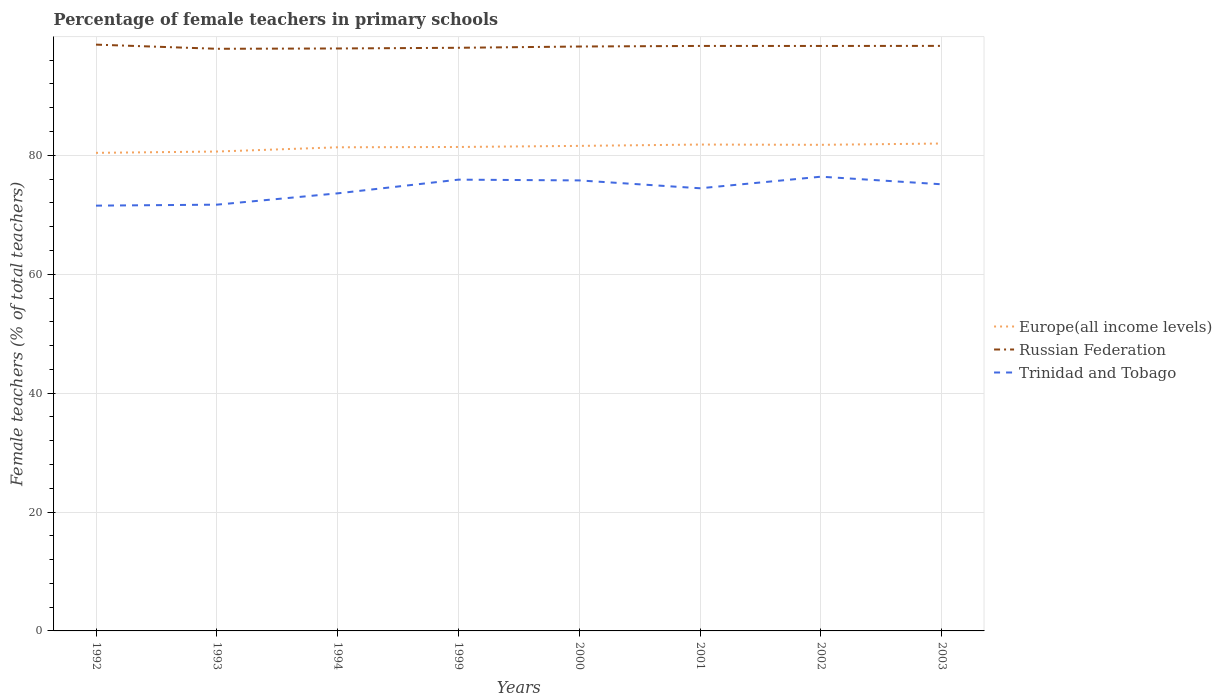How many different coloured lines are there?
Make the answer very short. 3. Does the line corresponding to Trinidad and Tobago intersect with the line corresponding to Europe(all income levels)?
Provide a succinct answer. No. Is the number of lines equal to the number of legend labels?
Your answer should be compact. Yes. Across all years, what is the maximum percentage of female teachers in Russian Federation?
Provide a short and direct response. 97.92. In which year was the percentage of female teachers in Trinidad and Tobago maximum?
Offer a very short reply. 1992. What is the total percentage of female teachers in Russian Federation in the graph?
Provide a succinct answer. -0.11. What is the difference between the highest and the second highest percentage of female teachers in Trinidad and Tobago?
Keep it short and to the point. 4.87. How many years are there in the graph?
Your answer should be very brief. 8. What is the difference between two consecutive major ticks on the Y-axis?
Your answer should be compact. 20. Does the graph contain grids?
Provide a succinct answer. Yes. What is the title of the graph?
Offer a very short reply. Percentage of female teachers in primary schools. What is the label or title of the Y-axis?
Give a very brief answer. Female teachers (% of total teachers). What is the Female teachers (% of total teachers) in Europe(all income levels) in 1992?
Offer a very short reply. 80.42. What is the Female teachers (% of total teachers) in Russian Federation in 1992?
Offer a very short reply. 98.62. What is the Female teachers (% of total teachers) in Trinidad and Tobago in 1992?
Make the answer very short. 71.54. What is the Female teachers (% of total teachers) in Europe(all income levels) in 1993?
Make the answer very short. 80.64. What is the Female teachers (% of total teachers) in Russian Federation in 1993?
Give a very brief answer. 97.92. What is the Female teachers (% of total teachers) of Trinidad and Tobago in 1993?
Provide a succinct answer. 71.7. What is the Female teachers (% of total teachers) in Europe(all income levels) in 1994?
Offer a very short reply. 81.35. What is the Female teachers (% of total teachers) in Russian Federation in 1994?
Your response must be concise. 97.97. What is the Female teachers (% of total teachers) of Trinidad and Tobago in 1994?
Your answer should be compact. 73.61. What is the Female teachers (% of total teachers) of Europe(all income levels) in 1999?
Offer a terse response. 81.41. What is the Female teachers (% of total teachers) in Russian Federation in 1999?
Offer a very short reply. 98.09. What is the Female teachers (% of total teachers) of Trinidad and Tobago in 1999?
Your response must be concise. 75.91. What is the Female teachers (% of total teachers) of Europe(all income levels) in 2000?
Offer a very short reply. 81.59. What is the Female teachers (% of total teachers) of Russian Federation in 2000?
Your response must be concise. 98.3. What is the Female teachers (% of total teachers) of Trinidad and Tobago in 2000?
Provide a succinct answer. 75.78. What is the Female teachers (% of total teachers) in Europe(all income levels) in 2001?
Your response must be concise. 81.81. What is the Female teachers (% of total teachers) of Russian Federation in 2001?
Ensure brevity in your answer.  98.4. What is the Female teachers (% of total teachers) of Trinidad and Tobago in 2001?
Offer a terse response. 74.46. What is the Female teachers (% of total teachers) of Europe(all income levels) in 2002?
Keep it short and to the point. 81.77. What is the Female teachers (% of total teachers) in Russian Federation in 2002?
Ensure brevity in your answer.  98.4. What is the Female teachers (% of total teachers) of Trinidad and Tobago in 2002?
Provide a short and direct response. 76.41. What is the Female teachers (% of total teachers) in Europe(all income levels) in 2003?
Offer a terse response. 81.99. What is the Female teachers (% of total teachers) in Russian Federation in 2003?
Provide a short and direct response. 98.41. What is the Female teachers (% of total teachers) of Trinidad and Tobago in 2003?
Make the answer very short. 75.13. Across all years, what is the maximum Female teachers (% of total teachers) of Europe(all income levels)?
Keep it short and to the point. 81.99. Across all years, what is the maximum Female teachers (% of total teachers) in Russian Federation?
Ensure brevity in your answer.  98.62. Across all years, what is the maximum Female teachers (% of total teachers) of Trinidad and Tobago?
Your answer should be compact. 76.41. Across all years, what is the minimum Female teachers (% of total teachers) of Europe(all income levels)?
Keep it short and to the point. 80.42. Across all years, what is the minimum Female teachers (% of total teachers) in Russian Federation?
Your answer should be very brief. 97.92. Across all years, what is the minimum Female teachers (% of total teachers) of Trinidad and Tobago?
Your response must be concise. 71.54. What is the total Female teachers (% of total teachers) in Europe(all income levels) in the graph?
Your response must be concise. 650.98. What is the total Female teachers (% of total teachers) in Russian Federation in the graph?
Keep it short and to the point. 786.13. What is the total Female teachers (% of total teachers) of Trinidad and Tobago in the graph?
Keep it short and to the point. 594.53. What is the difference between the Female teachers (% of total teachers) of Europe(all income levels) in 1992 and that in 1993?
Your response must be concise. -0.22. What is the difference between the Female teachers (% of total teachers) of Russian Federation in 1992 and that in 1993?
Keep it short and to the point. 0.7. What is the difference between the Female teachers (% of total teachers) of Trinidad and Tobago in 1992 and that in 1993?
Your answer should be compact. -0.16. What is the difference between the Female teachers (% of total teachers) of Europe(all income levels) in 1992 and that in 1994?
Offer a terse response. -0.93. What is the difference between the Female teachers (% of total teachers) of Russian Federation in 1992 and that in 1994?
Your response must be concise. 0.65. What is the difference between the Female teachers (% of total teachers) in Trinidad and Tobago in 1992 and that in 1994?
Your response must be concise. -2.07. What is the difference between the Female teachers (% of total teachers) in Europe(all income levels) in 1992 and that in 1999?
Give a very brief answer. -0.99. What is the difference between the Female teachers (% of total teachers) of Russian Federation in 1992 and that in 1999?
Offer a terse response. 0.53. What is the difference between the Female teachers (% of total teachers) of Trinidad and Tobago in 1992 and that in 1999?
Offer a terse response. -4.37. What is the difference between the Female teachers (% of total teachers) of Europe(all income levels) in 1992 and that in 2000?
Give a very brief answer. -1.17. What is the difference between the Female teachers (% of total teachers) of Russian Federation in 1992 and that in 2000?
Offer a very short reply. 0.32. What is the difference between the Female teachers (% of total teachers) in Trinidad and Tobago in 1992 and that in 2000?
Your response must be concise. -4.24. What is the difference between the Female teachers (% of total teachers) of Europe(all income levels) in 1992 and that in 2001?
Offer a very short reply. -1.4. What is the difference between the Female teachers (% of total teachers) of Russian Federation in 1992 and that in 2001?
Ensure brevity in your answer.  0.22. What is the difference between the Female teachers (% of total teachers) in Trinidad and Tobago in 1992 and that in 2001?
Offer a terse response. -2.92. What is the difference between the Female teachers (% of total teachers) of Europe(all income levels) in 1992 and that in 2002?
Give a very brief answer. -1.35. What is the difference between the Female teachers (% of total teachers) of Russian Federation in 1992 and that in 2002?
Your answer should be compact. 0.22. What is the difference between the Female teachers (% of total teachers) in Trinidad and Tobago in 1992 and that in 2002?
Provide a short and direct response. -4.87. What is the difference between the Female teachers (% of total teachers) in Europe(all income levels) in 1992 and that in 2003?
Offer a very short reply. -1.57. What is the difference between the Female teachers (% of total teachers) in Russian Federation in 1992 and that in 2003?
Your answer should be compact. 0.21. What is the difference between the Female teachers (% of total teachers) of Trinidad and Tobago in 1992 and that in 2003?
Offer a very short reply. -3.59. What is the difference between the Female teachers (% of total teachers) in Europe(all income levels) in 1993 and that in 1994?
Offer a very short reply. -0.71. What is the difference between the Female teachers (% of total teachers) in Russian Federation in 1993 and that in 1994?
Provide a short and direct response. -0.05. What is the difference between the Female teachers (% of total teachers) in Trinidad and Tobago in 1993 and that in 1994?
Provide a succinct answer. -1.9. What is the difference between the Female teachers (% of total teachers) in Europe(all income levels) in 1993 and that in 1999?
Provide a succinct answer. -0.77. What is the difference between the Female teachers (% of total teachers) of Russian Federation in 1993 and that in 1999?
Provide a succinct answer. -0.17. What is the difference between the Female teachers (% of total teachers) in Trinidad and Tobago in 1993 and that in 1999?
Your answer should be very brief. -4.21. What is the difference between the Female teachers (% of total teachers) of Europe(all income levels) in 1993 and that in 2000?
Provide a succinct answer. -0.95. What is the difference between the Female teachers (% of total teachers) in Russian Federation in 1993 and that in 2000?
Give a very brief answer. -0.38. What is the difference between the Female teachers (% of total teachers) in Trinidad and Tobago in 1993 and that in 2000?
Give a very brief answer. -4.08. What is the difference between the Female teachers (% of total teachers) in Europe(all income levels) in 1993 and that in 2001?
Offer a very short reply. -1.17. What is the difference between the Female teachers (% of total teachers) in Russian Federation in 1993 and that in 2001?
Provide a succinct answer. -0.48. What is the difference between the Female teachers (% of total teachers) of Trinidad and Tobago in 1993 and that in 2001?
Your response must be concise. -2.76. What is the difference between the Female teachers (% of total teachers) of Europe(all income levels) in 1993 and that in 2002?
Provide a short and direct response. -1.13. What is the difference between the Female teachers (% of total teachers) of Russian Federation in 1993 and that in 2002?
Offer a terse response. -0.48. What is the difference between the Female teachers (% of total teachers) in Trinidad and Tobago in 1993 and that in 2002?
Give a very brief answer. -4.71. What is the difference between the Female teachers (% of total teachers) of Europe(all income levels) in 1993 and that in 2003?
Your response must be concise. -1.35. What is the difference between the Female teachers (% of total teachers) of Russian Federation in 1993 and that in 2003?
Make the answer very short. -0.49. What is the difference between the Female teachers (% of total teachers) of Trinidad and Tobago in 1993 and that in 2003?
Ensure brevity in your answer.  -3.43. What is the difference between the Female teachers (% of total teachers) in Europe(all income levels) in 1994 and that in 1999?
Your answer should be compact. -0.06. What is the difference between the Female teachers (% of total teachers) of Russian Federation in 1994 and that in 1999?
Your answer should be compact. -0.12. What is the difference between the Female teachers (% of total teachers) of Trinidad and Tobago in 1994 and that in 1999?
Give a very brief answer. -2.3. What is the difference between the Female teachers (% of total teachers) of Europe(all income levels) in 1994 and that in 2000?
Offer a terse response. -0.24. What is the difference between the Female teachers (% of total teachers) in Russian Federation in 1994 and that in 2000?
Ensure brevity in your answer.  -0.33. What is the difference between the Female teachers (% of total teachers) in Trinidad and Tobago in 1994 and that in 2000?
Give a very brief answer. -2.18. What is the difference between the Female teachers (% of total teachers) of Europe(all income levels) in 1994 and that in 2001?
Keep it short and to the point. -0.46. What is the difference between the Female teachers (% of total teachers) of Russian Federation in 1994 and that in 2001?
Your answer should be compact. -0.43. What is the difference between the Female teachers (% of total teachers) in Trinidad and Tobago in 1994 and that in 2001?
Make the answer very short. -0.85. What is the difference between the Female teachers (% of total teachers) of Europe(all income levels) in 1994 and that in 2002?
Ensure brevity in your answer.  -0.42. What is the difference between the Female teachers (% of total teachers) in Russian Federation in 1994 and that in 2002?
Ensure brevity in your answer.  -0.42. What is the difference between the Female teachers (% of total teachers) in Trinidad and Tobago in 1994 and that in 2002?
Your response must be concise. -2.8. What is the difference between the Female teachers (% of total teachers) of Europe(all income levels) in 1994 and that in 2003?
Provide a short and direct response. -0.64. What is the difference between the Female teachers (% of total teachers) of Russian Federation in 1994 and that in 2003?
Provide a succinct answer. -0.44. What is the difference between the Female teachers (% of total teachers) in Trinidad and Tobago in 1994 and that in 2003?
Provide a short and direct response. -1.52. What is the difference between the Female teachers (% of total teachers) in Europe(all income levels) in 1999 and that in 2000?
Your answer should be compact. -0.18. What is the difference between the Female teachers (% of total teachers) in Russian Federation in 1999 and that in 2000?
Offer a very short reply. -0.21. What is the difference between the Female teachers (% of total teachers) of Trinidad and Tobago in 1999 and that in 2000?
Provide a short and direct response. 0.13. What is the difference between the Female teachers (% of total teachers) of Europe(all income levels) in 1999 and that in 2001?
Offer a terse response. -0.41. What is the difference between the Female teachers (% of total teachers) of Russian Federation in 1999 and that in 2001?
Offer a terse response. -0.31. What is the difference between the Female teachers (% of total teachers) in Trinidad and Tobago in 1999 and that in 2001?
Your response must be concise. 1.45. What is the difference between the Female teachers (% of total teachers) in Europe(all income levels) in 1999 and that in 2002?
Your answer should be compact. -0.36. What is the difference between the Female teachers (% of total teachers) in Russian Federation in 1999 and that in 2002?
Make the answer very short. -0.31. What is the difference between the Female teachers (% of total teachers) in Trinidad and Tobago in 1999 and that in 2002?
Offer a very short reply. -0.5. What is the difference between the Female teachers (% of total teachers) of Europe(all income levels) in 1999 and that in 2003?
Ensure brevity in your answer.  -0.58. What is the difference between the Female teachers (% of total teachers) of Russian Federation in 1999 and that in 2003?
Provide a succinct answer. -0.32. What is the difference between the Female teachers (% of total teachers) of Trinidad and Tobago in 1999 and that in 2003?
Offer a terse response. 0.78. What is the difference between the Female teachers (% of total teachers) in Europe(all income levels) in 2000 and that in 2001?
Keep it short and to the point. -0.22. What is the difference between the Female teachers (% of total teachers) in Russian Federation in 2000 and that in 2001?
Provide a short and direct response. -0.1. What is the difference between the Female teachers (% of total teachers) in Trinidad and Tobago in 2000 and that in 2001?
Your answer should be compact. 1.32. What is the difference between the Female teachers (% of total teachers) in Europe(all income levels) in 2000 and that in 2002?
Offer a very short reply. -0.18. What is the difference between the Female teachers (% of total teachers) in Russian Federation in 2000 and that in 2002?
Provide a short and direct response. -0.09. What is the difference between the Female teachers (% of total teachers) in Trinidad and Tobago in 2000 and that in 2002?
Offer a very short reply. -0.63. What is the difference between the Female teachers (% of total teachers) in Europe(all income levels) in 2000 and that in 2003?
Keep it short and to the point. -0.4. What is the difference between the Female teachers (% of total teachers) in Russian Federation in 2000 and that in 2003?
Offer a very short reply. -0.11. What is the difference between the Female teachers (% of total teachers) in Trinidad and Tobago in 2000 and that in 2003?
Offer a terse response. 0.65. What is the difference between the Female teachers (% of total teachers) in Europe(all income levels) in 2001 and that in 2002?
Your answer should be very brief. 0.04. What is the difference between the Female teachers (% of total teachers) in Russian Federation in 2001 and that in 2002?
Provide a succinct answer. 0. What is the difference between the Female teachers (% of total teachers) of Trinidad and Tobago in 2001 and that in 2002?
Your answer should be compact. -1.95. What is the difference between the Female teachers (% of total teachers) in Europe(all income levels) in 2001 and that in 2003?
Offer a terse response. -0.17. What is the difference between the Female teachers (% of total teachers) of Russian Federation in 2001 and that in 2003?
Keep it short and to the point. -0.01. What is the difference between the Female teachers (% of total teachers) in Trinidad and Tobago in 2001 and that in 2003?
Ensure brevity in your answer.  -0.67. What is the difference between the Female teachers (% of total teachers) in Europe(all income levels) in 2002 and that in 2003?
Provide a short and direct response. -0.22. What is the difference between the Female teachers (% of total teachers) of Russian Federation in 2002 and that in 2003?
Make the answer very short. -0.01. What is the difference between the Female teachers (% of total teachers) of Trinidad and Tobago in 2002 and that in 2003?
Keep it short and to the point. 1.28. What is the difference between the Female teachers (% of total teachers) in Europe(all income levels) in 1992 and the Female teachers (% of total teachers) in Russian Federation in 1993?
Provide a succinct answer. -17.5. What is the difference between the Female teachers (% of total teachers) of Europe(all income levels) in 1992 and the Female teachers (% of total teachers) of Trinidad and Tobago in 1993?
Provide a short and direct response. 8.72. What is the difference between the Female teachers (% of total teachers) in Russian Federation in 1992 and the Female teachers (% of total teachers) in Trinidad and Tobago in 1993?
Your response must be concise. 26.92. What is the difference between the Female teachers (% of total teachers) in Europe(all income levels) in 1992 and the Female teachers (% of total teachers) in Russian Federation in 1994?
Your answer should be compact. -17.56. What is the difference between the Female teachers (% of total teachers) of Europe(all income levels) in 1992 and the Female teachers (% of total teachers) of Trinidad and Tobago in 1994?
Offer a very short reply. 6.81. What is the difference between the Female teachers (% of total teachers) of Russian Federation in 1992 and the Female teachers (% of total teachers) of Trinidad and Tobago in 1994?
Keep it short and to the point. 25.02. What is the difference between the Female teachers (% of total teachers) in Europe(all income levels) in 1992 and the Female teachers (% of total teachers) in Russian Federation in 1999?
Provide a succinct answer. -17.67. What is the difference between the Female teachers (% of total teachers) of Europe(all income levels) in 1992 and the Female teachers (% of total teachers) of Trinidad and Tobago in 1999?
Offer a terse response. 4.51. What is the difference between the Female teachers (% of total teachers) of Russian Federation in 1992 and the Female teachers (% of total teachers) of Trinidad and Tobago in 1999?
Ensure brevity in your answer.  22.71. What is the difference between the Female teachers (% of total teachers) of Europe(all income levels) in 1992 and the Female teachers (% of total teachers) of Russian Federation in 2000?
Ensure brevity in your answer.  -17.89. What is the difference between the Female teachers (% of total teachers) in Europe(all income levels) in 1992 and the Female teachers (% of total teachers) in Trinidad and Tobago in 2000?
Your answer should be very brief. 4.64. What is the difference between the Female teachers (% of total teachers) of Russian Federation in 1992 and the Female teachers (% of total teachers) of Trinidad and Tobago in 2000?
Your answer should be very brief. 22.84. What is the difference between the Female teachers (% of total teachers) in Europe(all income levels) in 1992 and the Female teachers (% of total teachers) in Russian Federation in 2001?
Your answer should be very brief. -17.98. What is the difference between the Female teachers (% of total teachers) in Europe(all income levels) in 1992 and the Female teachers (% of total teachers) in Trinidad and Tobago in 2001?
Ensure brevity in your answer.  5.96. What is the difference between the Female teachers (% of total teachers) in Russian Federation in 1992 and the Female teachers (% of total teachers) in Trinidad and Tobago in 2001?
Offer a terse response. 24.16. What is the difference between the Female teachers (% of total teachers) in Europe(all income levels) in 1992 and the Female teachers (% of total teachers) in Russian Federation in 2002?
Give a very brief answer. -17.98. What is the difference between the Female teachers (% of total teachers) in Europe(all income levels) in 1992 and the Female teachers (% of total teachers) in Trinidad and Tobago in 2002?
Provide a short and direct response. 4.01. What is the difference between the Female teachers (% of total teachers) of Russian Federation in 1992 and the Female teachers (% of total teachers) of Trinidad and Tobago in 2002?
Provide a succinct answer. 22.21. What is the difference between the Female teachers (% of total teachers) of Europe(all income levels) in 1992 and the Female teachers (% of total teachers) of Russian Federation in 2003?
Offer a terse response. -17.99. What is the difference between the Female teachers (% of total teachers) of Europe(all income levels) in 1992 and the Female teachers (% of total teachers) of Trinidad and Tobago in 2003?
Keep it short and to the point. 5.29. What is the difference between the Female teachers (% of total teachers) in Russian Federation in 1992 and the Female teachers (% of total teachers) in Trinidad and Tobago in 2003?
Your answer should be very brief. 23.49. What is the difference between the Female teachers (% of total teachers) of Europe(all income levels) in 1993 and the Female teachers (% of total teachers) of Russian Federation in 1994?
Offer a terse response. -17.34. What is the difference between the Female teachers (% of total teachers) in Europe(all income levels) in 1993 and the Female teachers (% of total teachers) in Trinidad and Tobago in 1994?
Keep it short and to the point. 7.03. What is the difference between the Female teachers (% of total teachers) of Russian Federation in 1993 and the Female teachers (% of total teachers) of Trinidad and Tobago in 1994?
Keep it short and to the point. 24.32. What is the difference between the Female teachers (% of total teachers) of Europe(all income levels) in 1993 and the Female teachers (% of total teachers) of Russian Federation in 1999?
Ensure brevity in your answer.  -17.45. What is the difference between the Female teachers (% of total teachers) in Europe(all income levels) in 1993 and the Female teachers (% of total teachers) in Trinidad and Tobago in 1999?
Offer a terse response. 4.73. What is the difference between the Female teachers (% of total teachers) in Russian Federation in 1993 and the Female teachers (% of total teachers) in Trinidad and Tobago in 1999?
Provide a succinct answer. 22.01. What is the difference between the Female teachers (% of total teachers) of Europe(all income levels) in 1993 and the Female teachers (% of total teachers) of Russian Federation in 2000?
Offer a terse response. -17.67. What is the difference between the Female teachers (% of total teachers) of Europe(all income levels) in 1993 and the Female teachers (% of total teachers) of Trinidad and Tobago in 2000?
Ensure brevity in your answer.  4.86. What is the difference between the Female teachers (% of total teachers) in Russian Federation in 1993 and the Female teachers (% of total teachers) in Trinidad and Tobago in 2000?
Keep it short and to the point. 22.14. What is the difference between the Female teachers (% of total teachers) of Europe(all income levels) in 1993 and the Female teachers (% of total teachers) of Russian Federation in 2001?
Give a very brief answer. -17.76. What is the difference between the Female teachers (% of total teachers) of Europe(all income levels) in 1993 and the Female teachers (% of total teachers) of Trinidad and Tobago in 2001?
Provide a short and direct response. 6.18. What is the difference between the Female teachers (% of total teachers) in Russian Federation in 1993 and the Female teachers (% of total teachers) in Trinidad and Tobago in 2001?
Your answer should be very brief. 23.46. What is the difference between the Female teachers (% of total teachers) in Europe(all income levels) in 1993 and the Female teachers (% of total teachers) in Russian Federation in 2002?
Offer a very short reply. -17.76. What is the difference between the Female teachers (% of total teachers) in Europe(all income levels) in 1993 and the Female teachers (% of total teachers) in Trinidad and Tobago in 2002?
Keep it short and to the point. 4.23. What is the difference between the Female teachers (% of total teachers) of Russian Federation in 1993 and the Female teachers (% of total teachers) of Trinidad and Tobago in 2002?
Keep it short and to the point. 21.51. What is the difference between the Female teachers (% of total teachers) of Europe(all income levels) in 1993 and the Female teachers (% of total teachers) of Russian Federation in 2003?
Provide a succinct answer. -17.77. What is the difference between the Female teachers (% of total teachers) of Europe(all income levels) in 1993 and the Female teachers (% of total teachers) of Trinidad and Tobago in 2003?
Keep it short and to the point. 5.51. What is the difference between the Female teachers (% of total teachers) of Russian Federation in 1993 and the Female teachers (% of total teachers) of Trinidad and Tobago in 2003?
Give a very brief answer. 22.79. What is the difference between the Female teachers (% of total teachers) of Europe(all income levels) in 1994 and the Female teachers (% of total teachers) of Russian Federation in 1999?
Make the answer very short. -16.74. What is the difference between the Female teachers (% of total teachers) in Europe(all income levels) in 1994 and the Female teachers (% of total teachers) in Trinidad and Tobago in 1999?
Keep it short and to the point. 5.44. What is the difference between the Female teachers (% of total teachers) in Russian Federation in 1994 and the Female teachers (% of total teachers) in Trinidad and Tobago in 1999?
Your answer should be very brief. 22.06. What is the difference between the Female teachers (% of total teachers) of Europe(all income levels) in 1994 and the Female teachers (% of total teachers) of Russian Federation in 2000?
Provide a short and direct response. -16.95. What is the difference between the Female teachers (% of total teachers) of Europe(all income levels) in 1994 and the Female teachers (% of total teachers) of Trinidad and Tobago in 2000?
Your answer should be very brief. 5.57. What is the difference between the Female teachers (% of total teachers) of Russian Federation in 1994 and the Female teachers (% of total teachers) of Trinidad and Tobago in 2000?
Provide a succinct answer. 22.19. What is the difference between the Female teachers (% of total teachers) of Europe(all income levels) in 1994 and the Female teachers (% of total teachers) of Russian Federation in 2001?
Your answer should be very brief. -17.05. What is the difference between the Female teachers (% of total teachers) of Europe(all income levels) in 1994 and the Female teachers (% of total teachers) of Trinidad and Tobago in 2001?
Your response must be concise. 6.89. What is the difference between the Female teachers (% of total teachers) in Russian Federation in 1994 and the Female teachers (% of total teachers) in Trinidad and Tobago in 2001?
Provide a succinct answer. 23.52. What is the difference between the Female teachers (% of total teachers) of Europe(all income levels) in 1994 and the Female teachers (% of total teachers) of Russian Federation in 2002?
Your answer should be compact. -17.05. What is the difference between the Female teachers (% of total teachers) in Europe(all income levels) in 1994 and the Female teachers (% of total teachers) in Trinidad and Tobago in 2002?
Offer a terse response. 4.94. What is the difference between the Female teachers (% of total teachers) of Russian Federation in 1994 and the Female teachers (% of total teachers) of Trinidad and Tobago in 2002?
Ensure brevity in your answer.  21.57. What is the difference between the Female teachers (% of total teachers) in Europe(all income levels) in 1994 and the Female teachers (% of total teachers) in Russian Federation in 2003?
Provide a succinct answer. -17.06. What is the difference between the Female teachers (% of total teachers) of Europe(all income levels) in 1994 and the Female teachers (% of total teachers) of Trinidad and Tobago in 2003?
Provide a succinct answer. 6.22. What is the difference between the Female teachers (% of total teachers) of Russian Federation in 1994 and the Female teachers (% of total teachers) of Trinidad and Tobago in 2003?
Provide a succinct answer. 22.85. What is the difference between the Female teachers (% of total teachers) of Europe(all income levels) in 1999 and the Female teachers (% of total teachers) of Russian Federation in 2000?
Keep it short and to the point. -16.9. What is the difference between the Female teachers (% of total teachers) in Europe(all income levels) in 1999 and the Female teachers (% of total teachers) in Trinidad and Tobago in 2000?
Your answer should be compact. 5.62. What is the difference between the Female teachers (% of total teachers) in Russian Federation in 1999 and the Female teachers (% of total teachers) in Trinidad and Tobago in 2000?
Provide a short and direct response. 22.31. What is the difference between the Female teachers (% of total teachers) in Europe(all income levels) in 1999 and the Female teachers (% of total teachers) in Russian Federation in 2001?
Give a very brief answer. -17. What is the difference between the Female teachers (% of total teachers) in Europe(all income levels) in 1999 and the Female teachers (% of total teachers) in Trinidad and Tobago in 2001?
Keep it short and to the point. 6.95. What is the difference between the Female teachers (% of total teachers) of Russian Federation in 1999 and the Female teachers (% of total teachers) of Trinidad and Tobago in 2001?
Your answer should be compact. 23.63. What is the difference between the Female teachers (% of total teachers) in Europe(all income levels) in 1999 and the Female teachers (% of total teachers) in Russian Federation in 2002?
Your answer should be very brief. -16.99. What is the difference between the Female teachers (% of total teachers) of Europe(all income levels) in 1999 and the Female teachers (% of total teachers) of Trinidad and Tobago in 2002?
Your answer should be compact. 5. What is the difference between the Female teachers (% of total teachers) of Russian Federation in 1999 and the Female teachers (% of total teachers) of Trinidad and Tobago in 2002?
Give a very brief answer. 21.68. What is the difference between the Female teachers (% of total teachers) in Europe(all income levels) in 1999 and the Female teachers (% of total teachers) in Russian Federation in 2003?
Your answer should be compact. -17. What is the difference between the Female teachers (% of total teachers) in Europe(all income levels) in 1999 and the Female teachers (% of total teachers) in Trinidad and Tobago in 2003?
Ensure brevity in your answer.  6.28. What is the difference between the Female teachers (% of total teachers) in Russian Federation in 1999 and the Female teachers (% of total teachers) in Trinidad and Tobago in 2003?
Provide a short and direct response. 22.96. What is the difference between the Female teachers (% of total teachers) in Europe(all income levels) in 2000 and the Female teachers (% of total teachers) in Russian Federation in 2001?
Keep it short and to the point. -16.81. What is the difference between the Female teachers (% of total teachers) of Europe(all income levels) in 2000 and the Female teachers (% of total teachers) of Trinidad and Tobago in 2001?
Offer a terse response. 7.13. What is the difference between the Female teachers (% of total teachers) in Russian Federation in 2000 and the Female teachers (% of total teachers) in Trinidad and Tobago in 2001?
Offer a very short reply. 23.84. What is the difference between the Female teachers (% of total teachers) in Europe(all income levels) in 2000 and the Female teachers (% of total teachers) in Russian Federation in 2002?
Your answer should be compact. -16.81. What is the difference between the Female teachers (% of total teachers) in Europe(all income levels) in 2000 and the Female teachers (% of total teachers) in Trinidad and Tobago in 2002?
Give a very brief answer. 5.18. What is the difference between the Female teachers (% of total teachers) of Russian Federation in 2000 and the Female teachers (% of total teachers) of Trinidad and Tobago in 2002?
Your answer should be very brief. 21.9. What is the difference between the Female teachers (% of total teachers) in Europe(all income levels) in 2000 and the Female teachers (% of total teachers) in Russian Federation in 2003?
Offer a terse response. -16.82. What is the difference between the Female teachers (% of total teachers) in Europe(all income levels) in 2000 and the Female teachers (% of total teachers) in Trinidad and Tobago in 2003?
Ensure brevity in your answer.  6.46. What is the difference between the Female teachers (% of total teachers) in Russian Federation in 2000 and the Female teachers (% of total teachers) in Trinidad and Tobago in 2003?
Your answer should be very brief. 23.18. What is the difference between the Female teachers (% of total teachers) in Europe(all income levels) in 2001 and the Female teachers (% of total teachers) in Russian Federation in 2002?
Make the answer very short. -16.59. What is the difference between the Female teachers (% of total teachers) in Europe(all income levels) in 2001 and the Female teachers (% of total teachers) in Trinidad and Tobago in 2002?
Your answer should be very brief. 5.41. What is the difference between the Female teachers (% of total teachers) of Russian Federation in 2001 and the Female teachers (% of total teachers) of Trinidad and Tobago in 2002?
Your answer should be very brief. 21.99. What is the difference between the Female teachers (% of total teachers) in Europe(all income levels) in 2001 and the Female teachers (% of total teachers) in Russian Federation in 2003?
Keep it short and to the point. -16.6. What is the difference between the Female teachers (% of total teachers) of Europe(all income levels) in 2001 and the Female teachers (% of total teachers) of Trinidad and Tobago in 2003?
Make the answer very short. 6.69. What is the difference between the Female teachers (% of total teachers) in Russian Federation in 2001 and the Female teachers (% of total teachers) in Trinidad and Tobago in 2003?
Keep it short and to the point. 23.27. What is the difference between the Female teachers (% of total teachers) in Europe(all income levels) in 2002 and the Female teachers (% of total teachers) in Russian Federation in 2003?
Offer a very short reply. -16.64. What is the difference between the Female teachers (% of total teachers) of Europe(all income levels) in 2002 and the Female teachers (% of total teachers) of Trinidad and Tobago in 2003?
Your response must be concise. 6.64. What is the difference between the Female teachers (% of total teachers) in Russian Federation in 2002 and the Female teachers (% of total teachers) in Trinidad and Tobago in 2003?
Keep it short and to the point. 23.27. What is the average Female teachers (% of total teachers) of Europe(all income levels) per year?
Keep it short and to the point. 81.37. What is the average Female teachers (% of total teachers) in Russian Federation per year?
Offer a terse response. 98.27. What is the average Female teachers (% of total teachers) in Trinidad and Tobago per year?
Offer a terse response. 74.32. In the year 1992, what is the difference between the Female teachers (% of total teachers) in Europe(all income levels) and Female teachers (% of total teachers) in Russian Federation?
Your answer should be compact. -18.2. In the year 1992, what is the difference between the Female teachers (% of total teachers) in Europe(all income levels) and Female teachers (% of total teachers) in Trinidad and Tobago?
Make the answer very short. 8.88. In the year 1992, what is the difference between the Female teachers (% of total teachers) in Russian Federation and Female teachers (% of total teachers) in Trinidad and Tobago?
Keep it short and to the point. 27.08. In the year 1993, what is the difference between the Female teachers (% of total teachers) in Europe(all income levels) and Female teachers (% of total teachers) in Russian Federation?
Offer a terse response. -17.28. In the year 1993, what is the difference between the Female teachers (% of total teachers) of Europe(all income levels) and Female teachers (% of total teachers) of Trinidad and Tobago?
Ensure brevity in your answer.  8.94. In the year 1993, what is the difference between the Female teachers (% of total teachers) of Russian Federation and Female teachers (% of total teachers) of Trinidad and Tobago?
Your answer should be compact. 26.22. In the year 1994, what is the difference between the Female teachers (% of total teachers) in Europe(all income levels) and Female teachers (% of total teachers) in Russian Federation?
Offer a very short reply. -16.62. In the year 1994, what is the difference between the Female teachers (% of total teachers) in Europe(all income levels) and Female teachers (% of total teachers) in Trinidad and Tobago?
Offer a terse response. 7.75. In the year 1994, what is the difference between the Female teachers (% of total teachers) of Russian Federation and Female teachers (% of total teachers) of Trinidad and Tobago?
Your answer should be very brief. 24.37. In the year 1999, what is the difference between the Female teachers (% of total teachers) of Europe(all income levels) and Female teachers (% of total teachers) of Russian Federation?
Ensure brevity in your answer.  -16.69. In the year 1999, what is the difference between the Female teachers (% of total teachers) of Europe(all income levels) and Female teachers (% of total teachers) of Trinidad and Tobago?
Ensure brevity in your answer.  5.5. In the year 1999, what is the difference between the Female teachers (% of total teachers) of Russian Federation and Female teachers (% of total teachers) of Trinidad and Tobago?
Give a very brief answer. 22.18. In the year 2000, what is the difference between the Female teachers (% of total teachers) of Europe(all income levels) and Female teachers (% of total teachers) of Russian Federation?
Offer a terse response. -16.71. In the year 2000, what is the difference between the Female teachers (% of total teachers) of Europe(all income levels) and Female teachers (% of total teachers) of Trinidad and Tobago?
Your response must be concise. 5.81. In the year 2000, what is the difference between the Female teachers (% of total teachers) in Russian Federation and Female teachers (% of total teachers) in Trinidad and Tobago?
Give a very brief answer. 22.52. In the year 2001, what is the difference between the Female teachers (% of total teachers) of Europe(all income levels) and Female teachers (% of total teachers) of Russian Federation?
Your answer should be very brief. -16.59. In the year 2001, what is the difference between the Female teachers (% of total teachers) of Europe(all income levels) and Female teachers (% of total teachers) of Trinidad and Tobago?
Offer a very short reply. 7.35. In the year 2001, what is the difference between the Female teachers (% of total teachers) in Russian Federation and Female teachers (% of total teachers) in Trinidad and Tobago?
Provide a succinct answer. 23.94. In the year 2002, what is the difference between the Female teachers (% of total teachers) in Europe(all income levels) and Female teachers (% of total teachers) in Russian Federation?
Make the answer very short. -16.63. In the year 2002, what is the difference between the Female teachers (% of total teachers) in Europe(all income levels) and Female teachers (% of total teachers) in Trinidad and Tobago?
Keep it short and to the point. 5.36. In the year 2002, what is the difference between the Female teachers (% of total teachers) of Russian Federation and Female teachers (% of total teachers) of Trinidad and Tobago?
Ensure brevity in your answer.  21.99. In the year 2003, what is the difference between the Female teachers (% of total teachers) in Europe(all income levels) and Female teachers (% of total teachers) in Russian Federation?
Offer a terse response. -16.42. In the year 2003, what is the difference between the Female teachers (% of total teachers) of Europe(all income levels) and Female teachers (% of total teachers) of Trinidad and Tobago?
Your answer should be very brief. 6.86. In the year 2003, what is the difference between the Female teachers (% of total teachers) in Russian Federation and Female teachers (% of total teachers) in Trinidad and Tobago?
Your response must be concise. 23.28. What is the ratio of the Female teachers (% of total teachers) in Europe(all income levels) in 1992 to that in 1993?
Keep it short and to the point. 1. What is the ratio of the Female teachers (% of total teachers) of Russian Federation in 1992 to that in 1993?
Give a very brief answer. 1.01. What is the ratio of the Female teachers (% of total teachers) of Trinidad and Tobago in 1992 to that in 1993?
Keep it short and to the point. 1. What is the ratio of the Female teachers (% of total teachers) in Europe(all income levels) in 1992 to that in 1994?
Make the answer very short. 0.99. What is the ratio of the Female teachers (% of total teachers) of Russian Federation in 1992 to that in 1994?
Your response must be concise. 1.01. What is the ratio of the Female teachers (% of total teachers) in Trinidad and Tobago in 1992 to that in 1994?
Give a very brief answer. 0.97. What is the ratio of the Female teachers (% of total teachers) in Europe(all income levels) in 1992 to that in 1999?
Your answer should be very brief. 0.99. What is the ratio of the Female teachers (% of total teachers) of Russian Federation in 1992 to that in 1999?
Keep it short and to the point. 1.01. What is the ratio of the Female teachers (% of total teachers) in Trinidad and Tobago in 1992 to that in 1999?
Provide a short and direct response. 0.94. What is the ratio of the Female teachers (% of total teachers) of Europe(all income levels) in 1992 to that in 2000?
Give a very brief answer. 0.99. What is the ratio of the Female teachers (% of total teachers) in Trinidad and Tobago in 1992 to that in 2000?
Provide a succinct answer. 0.94. What is the ratio of the Female teachers (% of total teachers) of Europe(all income levels) in 1992 to that in 2001?
Your response must be concise. 0.98. What is the ratio of the Female teachers (% of total teachers) in Russian Federation in 1992 to that in 2001?
Give a very brief answer. 1. What is the ratio of the Female teachers (% of total teachers) in Trinidad and Tobago in 1992 to that in 2001?
Your response must be concise. 0.96. What is the ratio of the Female teachers (% of total teachers) of Europe(all income levels) in 1992 to that in 2002?
Offer a very short reply. 0.98. What is the ratio of the Female teachers (% of total teachers) in Russian Federation in 1992 to that in 2002?
Give a very brief answer. 1. What is the ratio of the Female teachers (% of total teachers) of Trinidad and Tobago in 1992 to that in 2002?
Your response must be concise. 0.94. What is the ratio of the Female teachers (% of total teachers) in Europe(all income levels) in 1992 to that in 2003?
Ensure brevity in your answer.  0.98. What is the ratio of the Female teachers (% of total teachers) in Trinidad and Tobago in 1992 to that in 2003?
Offer a very short reply. 0.95. What is the ratio of the Female teachers (% of total teachers) of Russian Federation in 1993 to that in 1994?
Offer a very short reply. 1. What is the ratio of the Female teachers (% of total teachers) of Trinidad and Tobago in 1993 to that in 1994?
Keep it short and to the point. 0.97. What is the ratio of the Female teachers (% of total teachers) of Europe(all income levels) in 1993 to that in 1999?
Provide a succinct answer. 0.99. What is the ratio of the Female teachers (% of total teachers) in Russian Federation in 1993 to that in 1999?
Your response must be concise. 1. What is the ratio of the Female teachers (% of total teachers) in Trinidad and Tobago in 1993 to that in 1999?
Offer a very short reply. 0.94. What is the ratio of the Female teachers (% of total teachers) in Europe(all income levels) in 1993 to that in 2000?
Keep it short and to the point. 0.99. What is the ratio of the Female teachers (% of total teachers) of Russian Federation in 1993 to that in 2000?
Give a very brief answer. 1. What is the ratio of the Female teachers (% of total teachers) in Trinidad and Tobago in 1993 to that in 2000?
Ensure brevity in your answer.  0.95. What is the ratio of the Female teachers (% of total teachers) of Europe(all income levels) in 1993 to that in 2001?
Your answer should be compact. 0.99. What is the ratio of the Female teachers (% of total teachers) in Russian Federation in 1993 to that in 2001?
Keep it short and to the point. 1. What is the ratio of the Female teachers (% of total teachers) in Europe(all income levels) in 1993 to that in 2002?
Your answer should be compact. 0.99. What is the ratio of the Female teachers (% of total teachers) of Trinidad and Tobago in 1993 to that in 2002?
Keep it short and to the point. 0.94. What is the ratio of the Female teachers (% of total teachers) of Europe(all income levels) in 1993 to that in 2003?
Offer a very short reply. 0.98. What is the ratio of the Female teachers (% of total teachers) in Trinidad and Tobago in 1993 to that in 2003?
Provide a short and direct response. 0.95. What is the ratio of the Female teachers (% of total teachers) in Europe(all income levels) in 1994 to that in 1999?
Your response must be concise. 1. What is the ratio of the Female teachers (% of total teachers) in Trinidad and Tobago in 1994 to that in 1999?
Make the answer very short. 0.97. What is the ratio of the Female teachers (% of total teachers) in Trinidad and Tobago in 1994 to that in 2000?
Ensure brevity in your answer.  0.97. What is the ratio of the Female teachers (% of total teachers) of Russian Federation in 1994 to that in 2001?
Offer a very short reply. 1. What is the ratio of the Female teachers (% of total teachers) of Trinidad and Tobago in 1994 to that in 2001?
Give a very brief answer. 0.99. What is the ratio of the Female teachers (% of total teachers) of Europe(all income levels) in 1994 to that in 2002?
Your answer should be compact. 0.99. What is the ratio of the Female teachers (% of total teachers) of Trinidad and Tobago in 1994 to that in 2002?
Your answer should be very brief. 0.96. What is the ratio of the Female teachers (% of total teachers) in Russian Federation in 1994 to that in 2003?
Ensure brevity in your answer.  1. What is the ratio of the Female teachers (% of total teachers) of Trinidad and Tobago in 1994 to that in 2003?
Give a very brief answer. 0.98. What is the ratio of the Female teachers (% of total teachers) of Europe(all income levels) in 1999 to that in 2001?
Ensure brevity in your answer.  0.99. What is the ratio of the Female teachers (% of total teachers) in Trinidad and Tobago in 1999 to that in 2001?
Your response must be concise. 1.02. What is the ratio of the Female teachers (% of total teachers) in Russian Federation in 1999 to that in 2003?
Provide a succinct answer. 1. What is the ratio of the Female teachers (% of total teachers) in Trinidad and Tobago in 1999 to that in 2003?
Ensure brevity in your answer.  1.01. What is the ratio of the Female teachers (% of total teachers) of Europe(all income levels) in 2000 to that in 2001?
Your response must be concise. 1. What is the ratio of the Female teachers (% of total teachers) of Trinidad and Tobago in 2000 to that in 2001?
Offer a very short reply. 1.02. What is the ratio of the Female teachers (% of total teachers) in Europe(all income levels) in 2000 to that in 2002?
Provide a short and direct response. 1. What is the ratio of the Female teachers (% of total teachers) of Trinidad and Tobago in 2000 to that in 2003?
Make the answer very short. 1.01. What is the ratio of the Female teachers (% of total teachers) of Europe(all income levels) in 2001 to that in 2002?
Provide a short and direct response. 1. What is the ratio of the Female teachers (% of total teachers) in Russian Federation in 2001 to that in 2002?
Provide a succinct answer. 1. What is the ratio of the Female teachers (% of total teachers) in Trinidad and Tobago in 2001 to that in 2002?
Offer a very short reply. 0.97. What is the ratio of the Female teachers (% of total teachers) of Trinidad and Tobago in 2001 to that in 2003?
Your response must be concise. 0.99. What is the ratio of the Female teachers (% of total teachers) of Europe(all income levels) in 2002 to that in 2003?
Provide a succinct answer. 1. What is the ratio of the Female teachers (% of total teachers) of Russian Federation in 2002 to that in 2003?
Your answer should be compact. 1. What is the difference between the highest and the second highest Female teachers (% of total teachers) of Europe(all income levels)?
Your answer should be compact. 0.17. What is the difference between the highest and the second highest Female teachers (% of total teachers) in Russian Federation?
Offer a very short reply. 0.21. What is the difference between the highest and the second highest Female teachers (% of total teachers) in Trinidad and Tobago?
Provide a succinct answer. 0.5. What is the difference between the highest and the lowest Female teachers (% of total teachers) of Europe(all income levels)?
Provide a succinct answer. 1.57. What is the difference between the highest and the lowest Female teachers (% of total teachers) of Russian Federation?
Offer a terse response. 0.7. What is the difference between the highest and the lowest Female teachers (% of total teachers) of Trinidad and Tobago?
Provide a succinct answer. 4.87. 